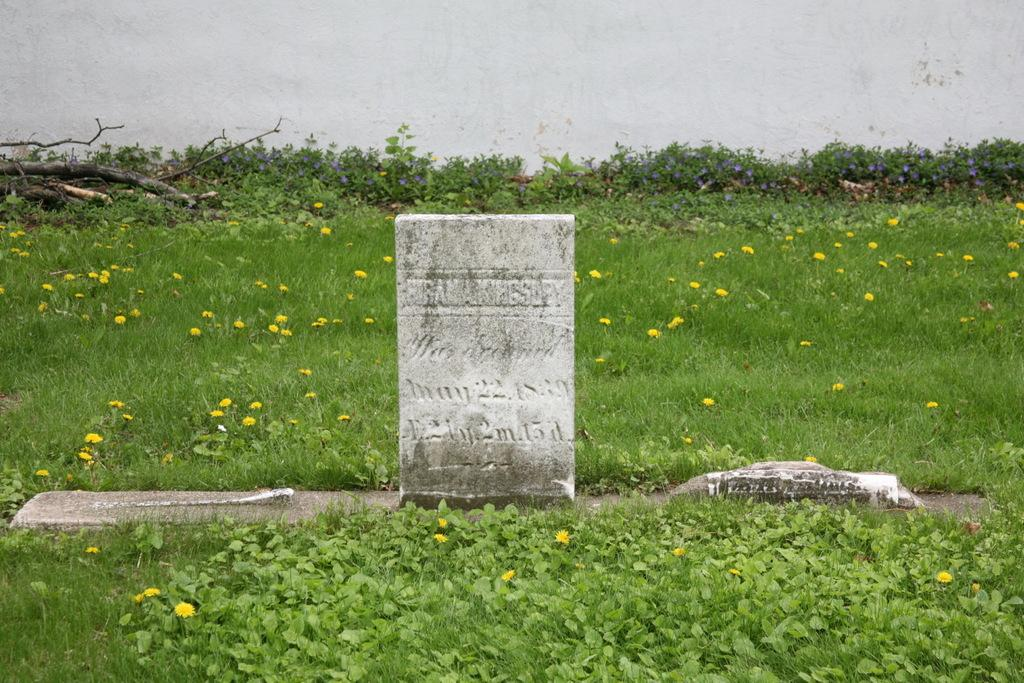What is the main object in the picture? There is a gravestone in the picture. What can be seen around the gravestone? There are small plants and grass around the gravestone. What is visible in the background of the picture? There is a wall in the background of the picture. How many crackers are on the gravestone in the image? There are no crackers present on the gravestone in the image. Can you see any sheep grazing near the gravestone? There are no sheep visible in the image; it only features a gravestone, small plants, grass, and a wall in the background. 